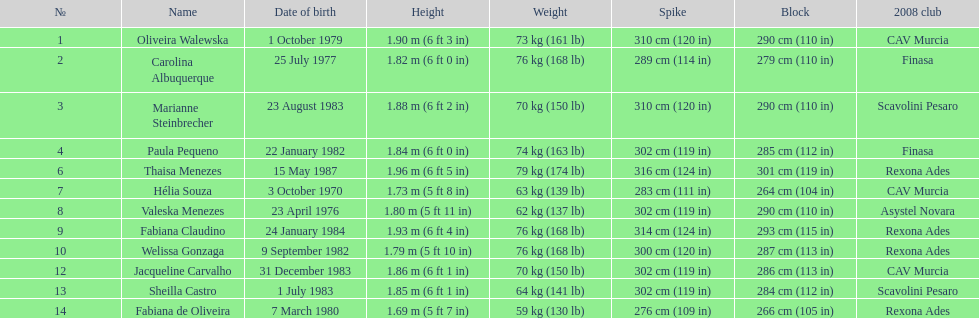Whose weight is the heaviest among the following: fabiana de oliveira, helia souza, or sheilla castro? Sheilla Castro. 